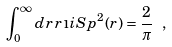<formula> <loc_0><loc_0><loc_500><loc_500>\int _ { 0 } ^ { \infty } d r \, r \, \i i S p ^ { 2 } ( r ) = \frac { 2 } { \pi } \ ,</formula> 